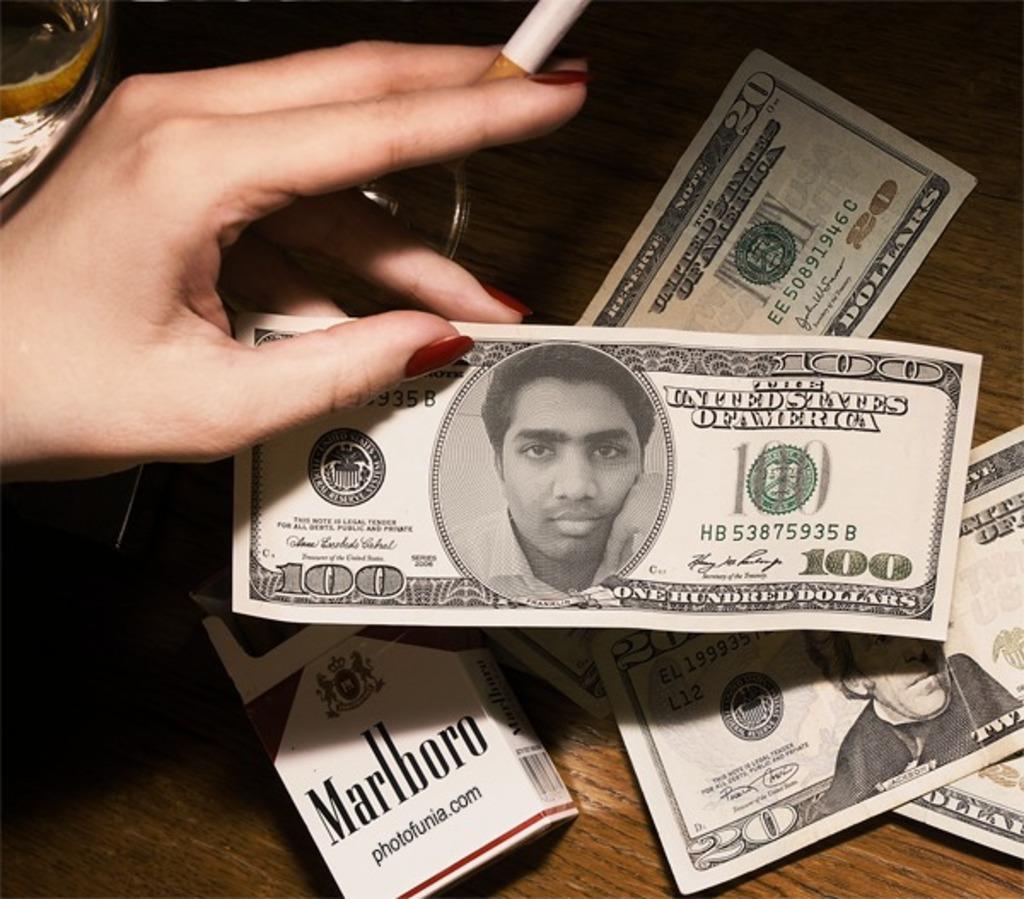In one or two sentences, can you explain what this image depicts? In the image there are dollar notes,cigarette pack on a table and a lady holding cigarette and a note. 